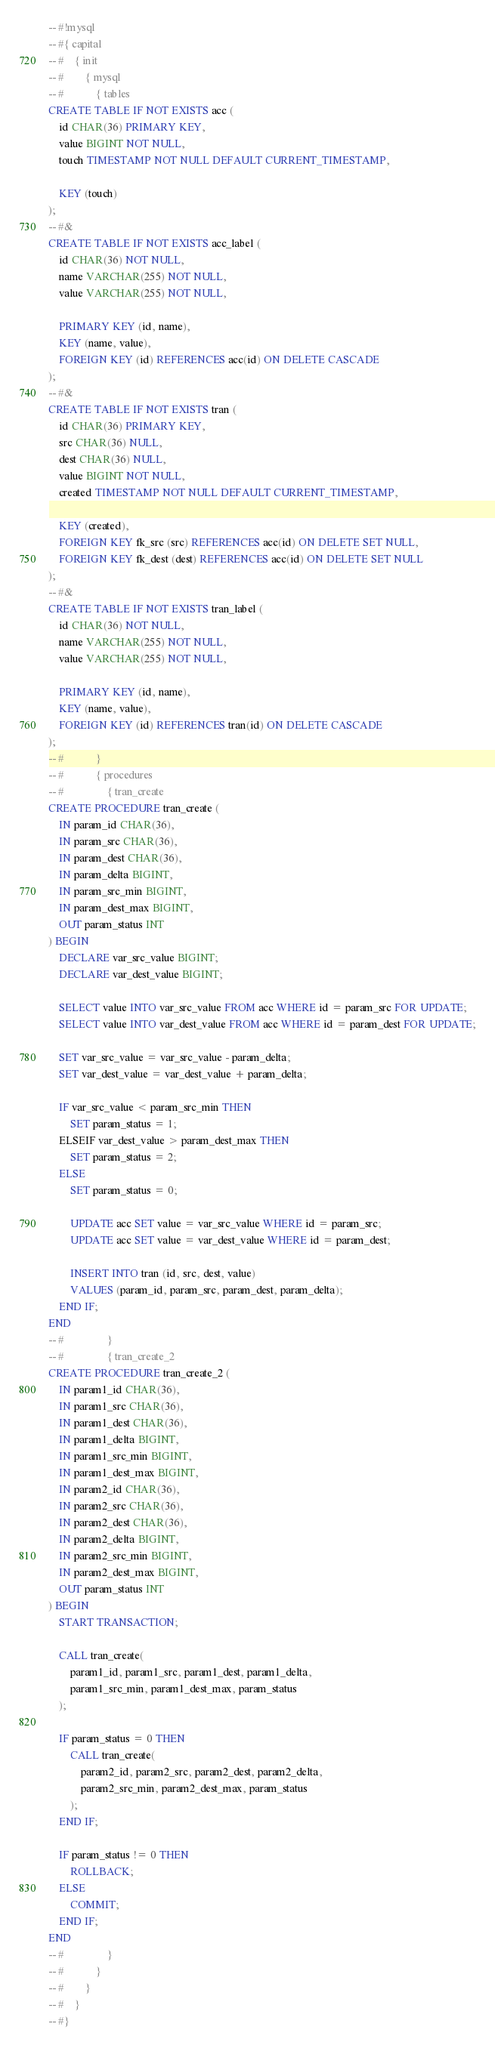<code> <loc_0><loc_0><loc_500><loc_500><_SQL_>-- #!mysql
-- #{ capital
-- #    { init
-- #        { mysql
-- #            { tables
CREATE TABLE IF NOT EXISTS acc (
    id CHAR(36) PRIMARY KEY,
    value BIGINT NOT NULL,
    touch TIMESTAMP NOT NULL DEFAULT CURRENT_TIMESTAMP,

    KEY (touch)
);
-- #&
CREATE TABLE IF NOT EXISTS acc_label (
    id CHAR(36) NOT NULL,
    name VARCHAR(255) NOT NULL,
    value VARCHAR(255) NOT NULL,

    PRIMARY KEY (id, name),
    KEY (name, value),
    FOREIGN KEY (id) REFERENCES acc(id) ON DELETE CASCADE
);
-- #&
CREATE TABLE IF NOT EXISTS tran (
    id CHAR(36) PRIMARY KEY,
    src CHAR(36) NULL,
    dest CHAR(36) NULL,
    value BIGINT NOT NULL,
    created TIMESTAMP NOT NULL DEFAULT CURRENT_TIMESTAMP,

    KEY (created),
    FOREIGN KEY fk_src (src) REFERENCES acc(id) ON DELETE SET NULL,
    FOREIGN KEY fk_dest (dest) REFERENCES acc(id) ON DELETE SET NULL
);
-- #&
CREATE TABLE IF NOT EXISTS tran_label (
    id CHAR(36) NOT NULL,
    name VARCHAR(255) NOT NULL,
    value VARCHAR(255) NOT NULL,

    PRIMARY KEY (id, name),
    KEY (name, value),
    FOREIGN KEY (id) REFERENCES tran(id) ON DELETE CASCADE
);
-- #            }
-- #            { procedures
-- #                { tran_create
CREATE PROCEDURE tran_create (
    IN param_id CHAR(36),
    IN param_src CHAR(36),
    IN param_dest CHAR(36),
    IN param_delta BIGINT,
    IN param_src_min BIGINT,
    IN param_dest_max BIGINT,
    OUT param_status INT
) BEGIN
    DECLARE var_src_value BIGINT;
    DECLARE var_dest_value BIGINT;

    SELECT value INTO var_src_value FROM acc WHERE id = param_src FOR UPDATE;
    SELECT value INTO var_dest_value FROM acc WHERE id = param_dest FOR UPDATE;

    SET var_src_value = var_src_value - param_delta;
    SET var_dest_value = var_dest_value + param_delta;

    IF var_src_value < param_src_min THEN
        SET param_status = 1;
    ELSEIF var_dest_value > param_dest_max THEN
        SET param_status = 2;
    ELSE
        SET param_status = 0;

        UPDATE acc SET value = var_src_value WHERE id = param_src;
        UPDATE acc SET value = var_dest_value WHERE id = param_dest;

        INSERT INTO tran (id, src, dest, value)
        VALUES (param_id, param_src, param_dest, param_delta);
    END IF;
END
-- #                }
-- #                { tran_create_2
CREATE PROCEDURE tran_create_2 (
    IN param1_id CHAR(36),
    IN param1_src CHAR(36),
    IN param1_dest CHAR(36),
    IN param1_delta BIGINT,
    IN param1_src_min BIGINT,
    IN param1_dest_max BIGINT,
    IN param2_id CHAR(36),
    IN param2_src CHAR(36),
    IN param2_dest CHAR(36),
    IN param2_delta BIGINT,
    IN param2_src_min BIGINT,
    IN param2_dest_max BIGINT,
    OUT param_status INT
) BEGIN
    START TRANSACTION;

    CALL tran_create(
        param1_id, param1_src, param1_dest, param1_delta,
        param1_src_min, param1_dest_max, param_status
    );

    IF param_status = 0 THEN
        CALL tran_create(
            param2_id, param2_src, param2_dest, param2_delta,
            param2_src_min, param2_dest_max, param_status
        );
    END IF;

    IF param_status != 0 THEN
        ROLLBACK;
    ELSE
        COMMIT;
    END IF;
END
-- #                }
-- #            }
-- #        }
-- #    }
-- #}
</code> 